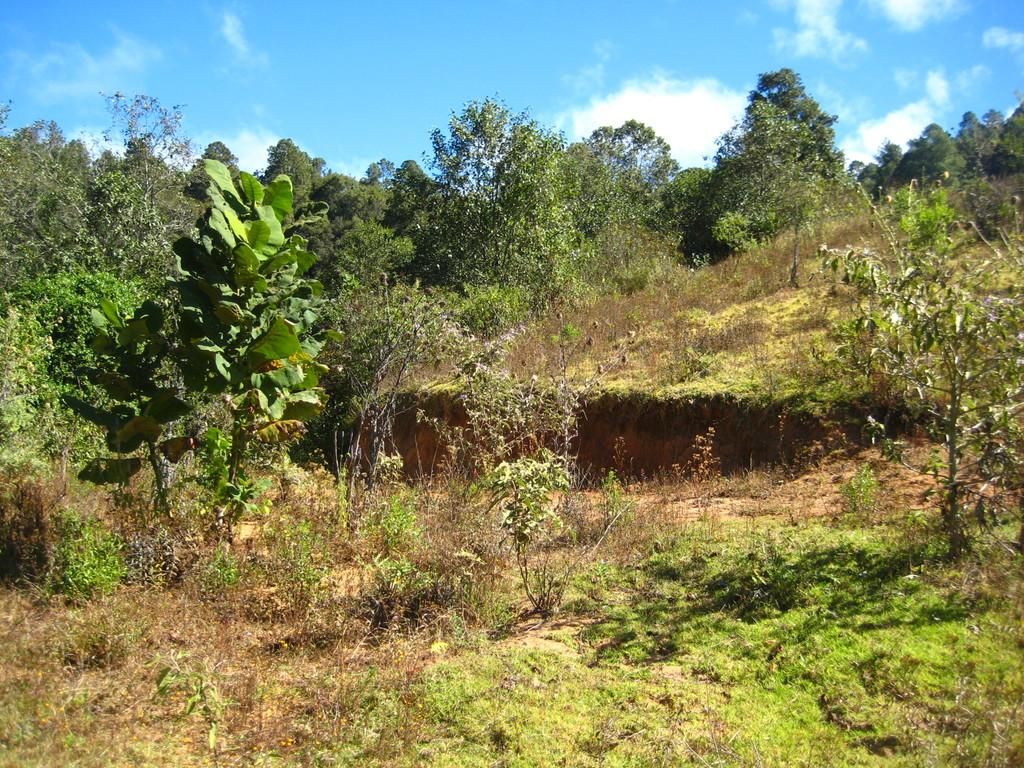What type of vegetation can be seen in the image? There are trees in the image. What is visible in the background of the image? The sky is visible in the background of the image. What can be observed in the sky? Clouds are present in the sky. How many cherries are hanging from the trees in the image? There are no cherries present in the image; it only features trees. Who is the creator of the clouds in the image? The clouds in the image are a natural weather phenomenon and are not created by any individual. 